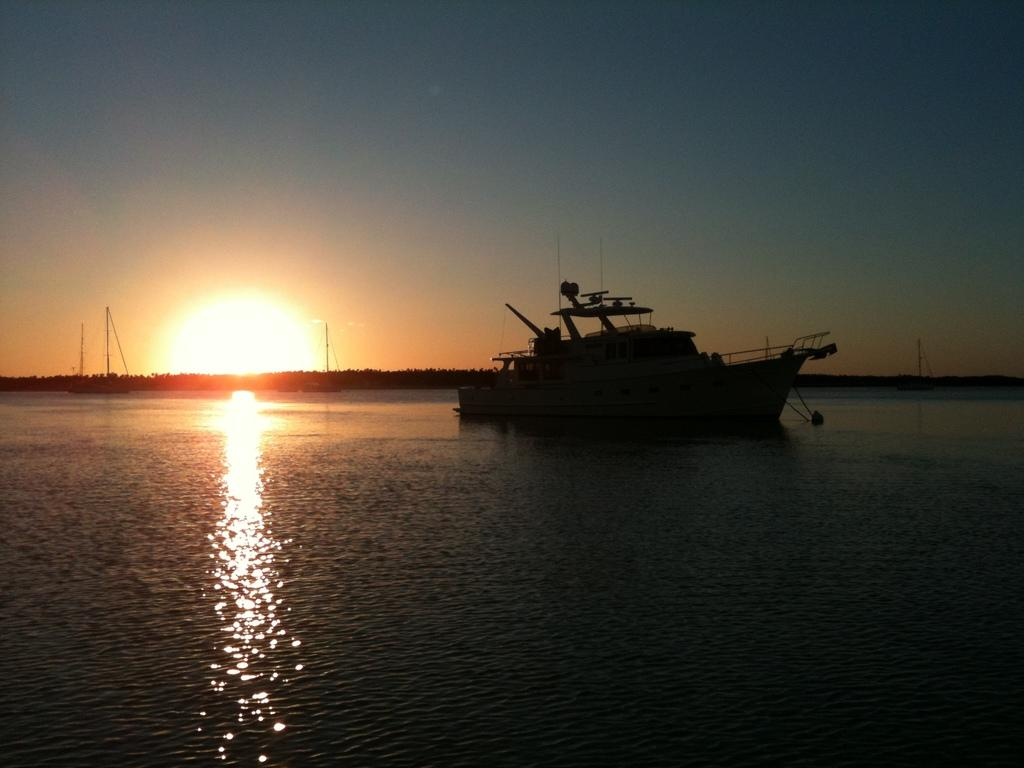What is the main subject in the middle of the image? There is a ship in the middle of the image. Are there any other ships visible in the image? Yes, there are other ships visible in the background. What is the location of the ships in the image? The ships are on water. What can be seen in the image besides the ships? Sunlight and the sky are visible in the image. What type of window can be seen on the ship in the image? There is no window visible on the ship in the image. What is the box used for in the image? There is no box present in the image. 